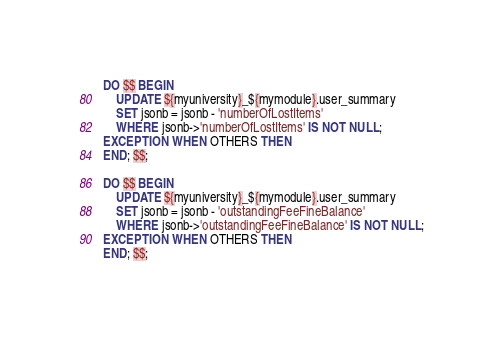Convert code to text. <code><loc_0><loc_0><loc_500><loc_500><_SQL_>DO $$ BEGIN
    UPDATE ${myuniversity}_${mymodule}.user_summary
    SET jsonb = jsonb - 'numberOfLostItems'
    WHERE jsonb->'numberOfLostItems' IS NOT NULL;
EXCEPTION WHEN OTHERS THEN
END; $$;

DO $$ BEGIN
    UPDATE ${myuniversity}_${mymodule}.user_summary
    SET jsonb = jsonb - 'outstandingFeeFineBalance'
    WHERE jsonb->'outstandingFeeFineBalance' IS NOT NULL;
EXCEPTION WHEN OTHERS THEN
END; $$;
</code> 